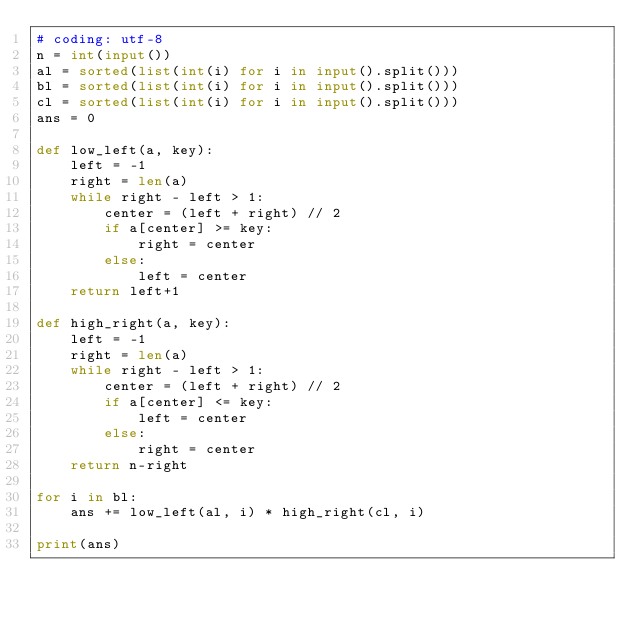Convert code to text. <code><loc_0><loc_0><loc_500><loc_500><_Python_># coding: utf-8
n = int(input())
al = sorted(list(int(i) for i in input().split()))
bl = sorted(list(int(i) for i in input().split()))
cl = sorted(list(int(i) for i in input().split()))
ans = 0

def low_left(a, key):
    left = -1
    right = len(a)
    while right - left > 1:
        center = (left + right) // 2
        if a[center] >= key:
            right = center
        else:
            left = center
    return left+1 
    
def high_right(a, key):
    left = -1
    right = len(a)
    while right - left > 1:
        center = (left + right) // 2
        if a[center] <= key:
            left = center
        else:
            right = center
    return n-right
    
for i in bl:
    ans += low_left(al, i) * high_right(cl, i)

print(ans)</code> 